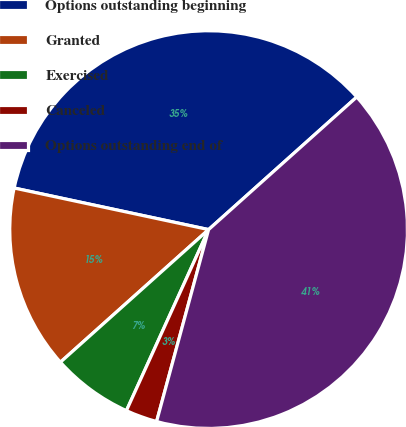Convert chart. <chart><loc_0><loc_0><loc_500><loc_500><pie_chart><fcel>Options outstanding beginning<fcel>Granted<fcel>Exercised<fcel>Canceled<fcel>Options outstanding end of<nl><fcel>35.03%<fcel>14.97%<fcel>6.6%<fcel>2.57%<fcel>40.83%<nl></chart> 